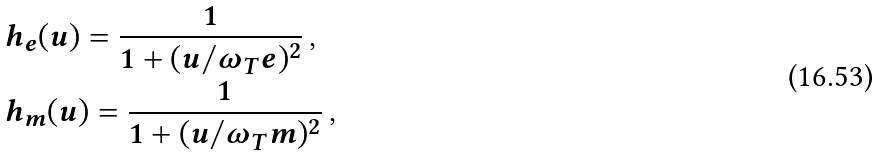Convert formula to latex. <formula><loc_0><loc_0><loc_500><loc_500>& h _ { e } ( u ) = \frac { 1 } { 1 + ( u / \omega _ { T } e ) ^ { 2 } } \, , \\ & h _ { m } ( u ) = \frac { 1 } { 1 + ( u / \omega _ { T } m ) ^ { 2 } } \, ,</formula> 